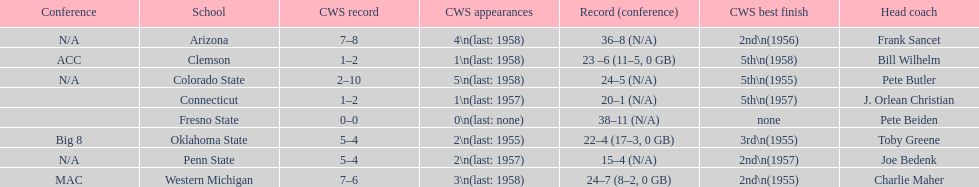List the schools that came in last place in the cws best finish. Clemson, Colorado State, Connecticut. 